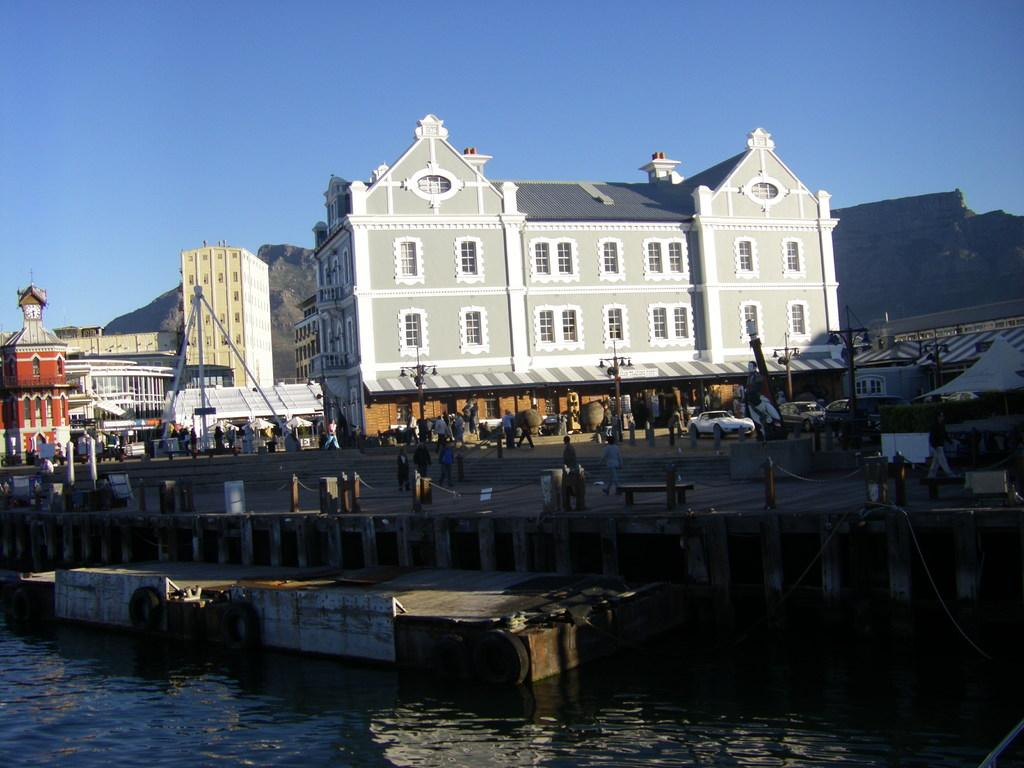What is the main feature of the image? The main feature of the image is a water surface with an iron sheet on it. What can be seen in the background of the image? In the background, there are people walking on a road, houses, and the sky. Can you describe the iron sheet on the water surface? The iron sheet appears to be floating or resting on the water surface. How many sheep are visible in the image? There are no sheep present in the image. What day of the week is it in the image? The day of the week cannot be determined from the image. 